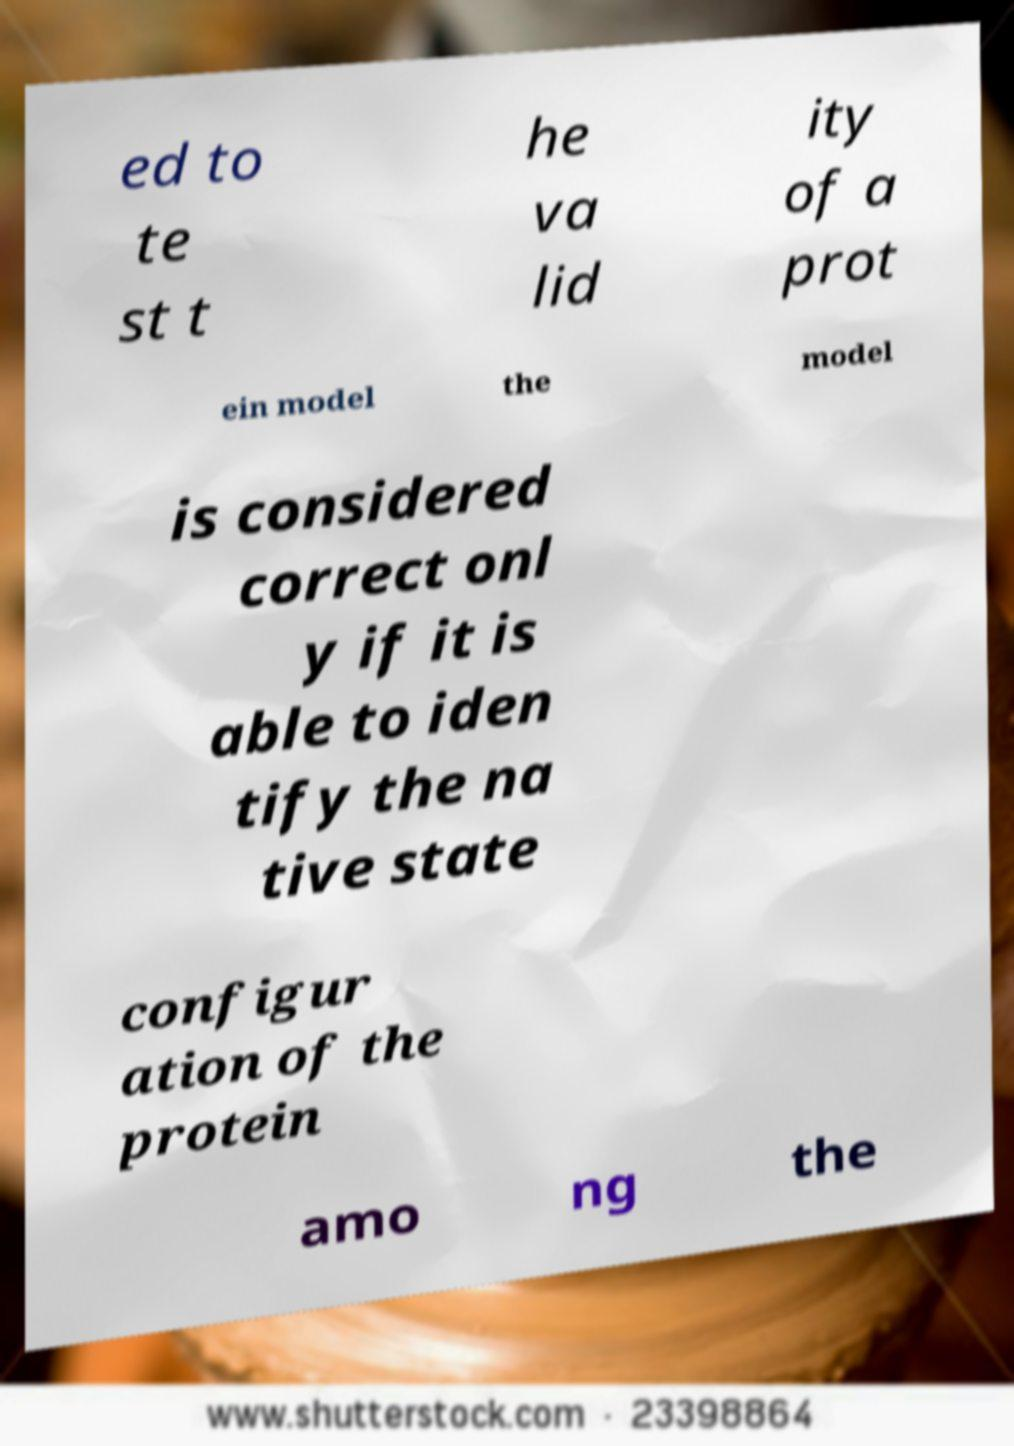What messages or text are displayed in this image? I need them in a readable, typed format. ed to te st t he va lid ity of a prot ein model the model is considered correct onl y if it is able to iden tify the na tive state configur ation of the protein amo ng the 